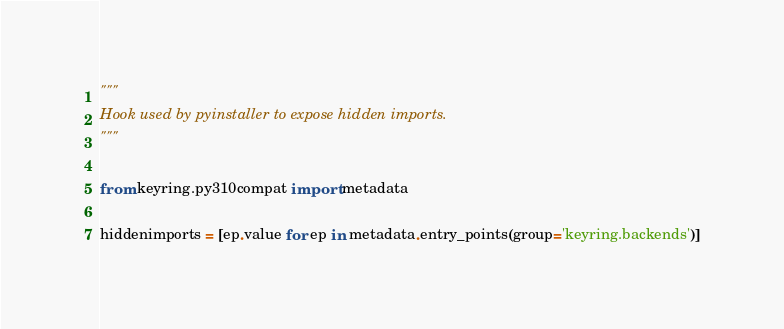Convert code to text. <code><loc_0><loc_0><loc_500><loc_500><_Python_>"""
Hook used by pyinstaller to expose hidden imports.
"""

from keyring.py310compat import metadata

hiddenimports = [ep.value for ep in metadata.entry_points(group='keyring.backends')]
</code> 